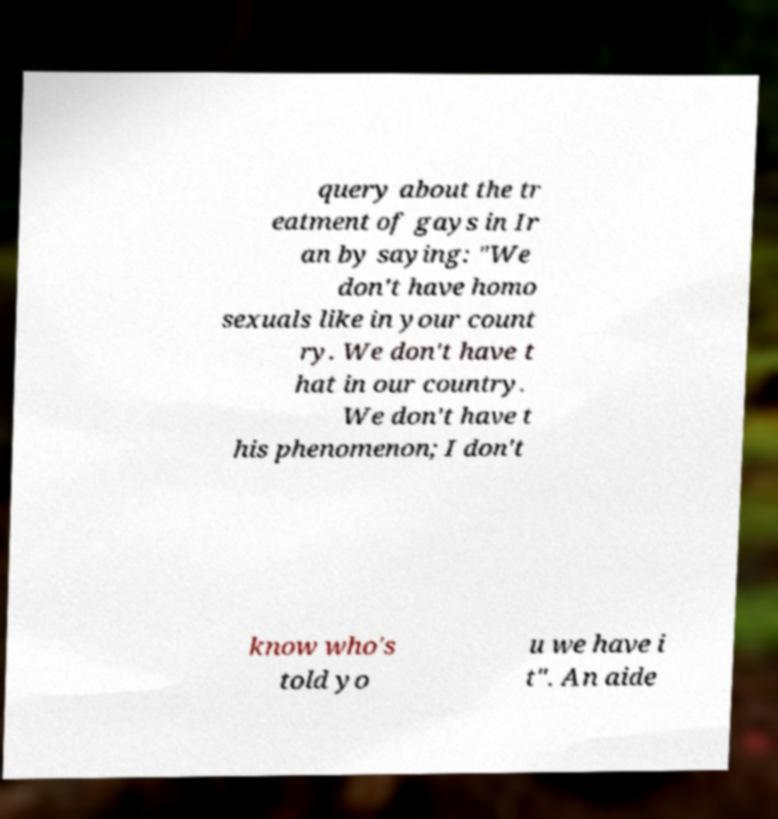What messages or text are displayed in this image? I need them in a readable, typed format. query about the tr eatment of gays in Ir an by saying: "We don't have homo sexuals like in your count ry. We don't have t hat in our country. We don't have t his phenomenon; I don't know who's told yo u we have i t". An aide 